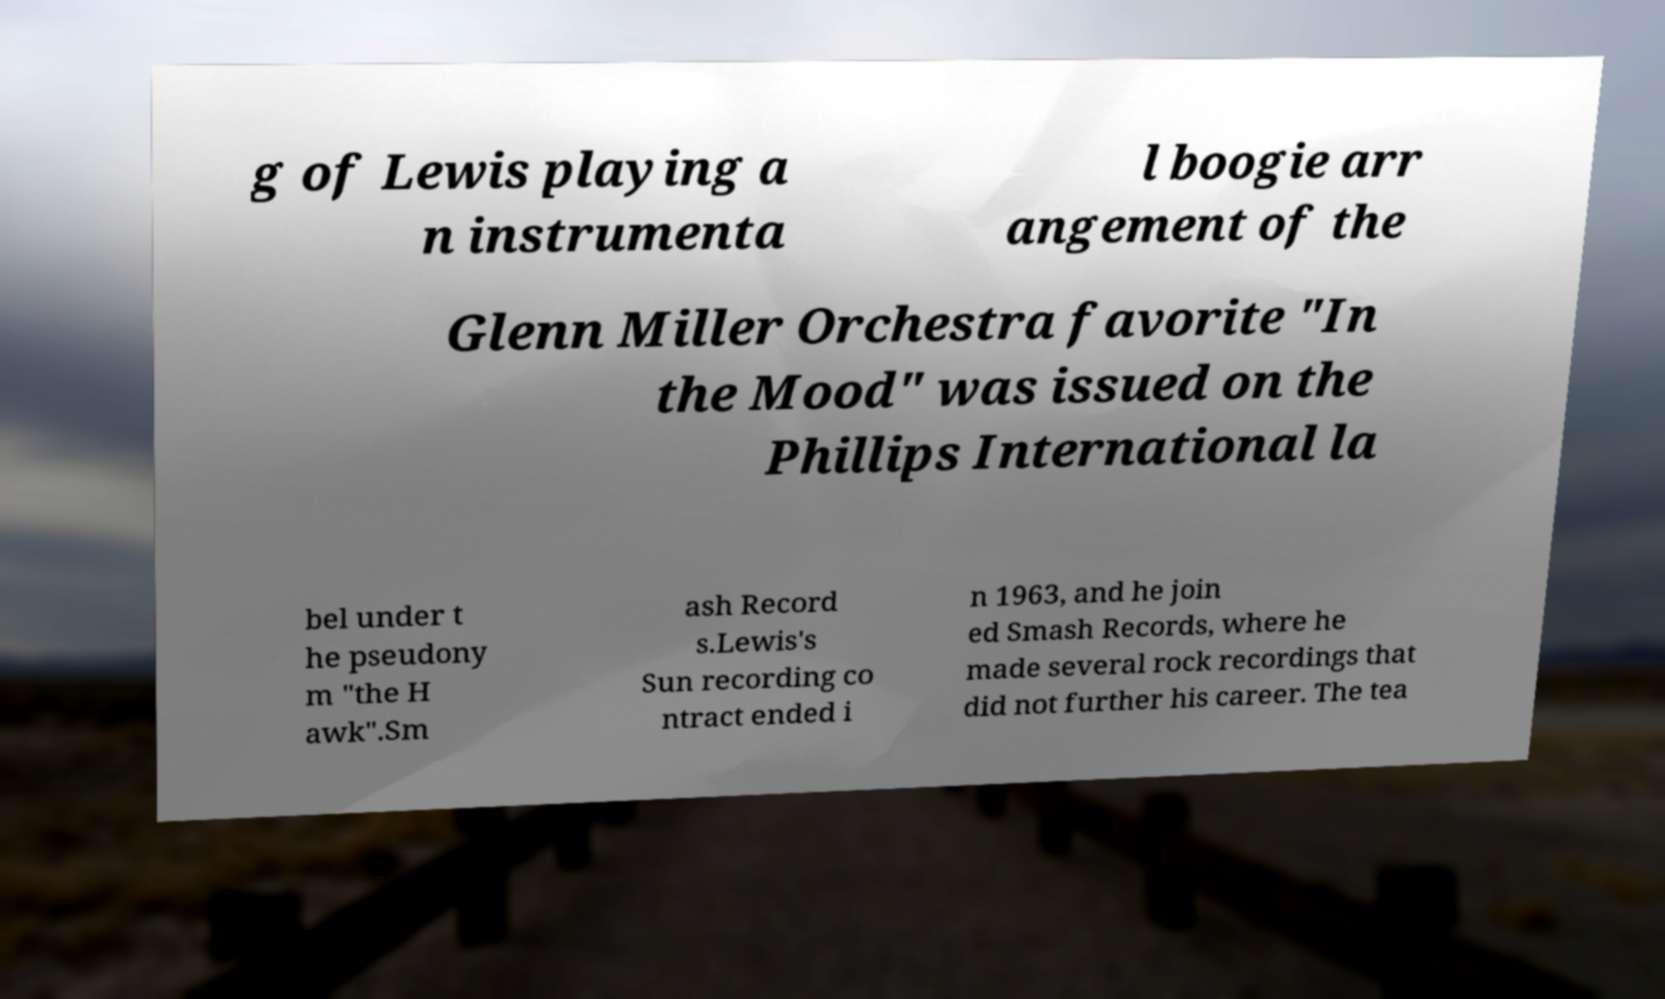For documentation purposes, I need the text within this image transcribed. Could you provide that? g of Lewis playing a n instrumenta l boogie arr angement of the Glenn Miller Orchestra favorite "In the Mood" was issued on the Phillips International la bel under t he pseudony m "the H awk".Sm ash Record s.Lewis's Sun recording co ntract ended i n 1963, and he join ed Smash Records, where he made several rock recordings that did not further his career. The tea 